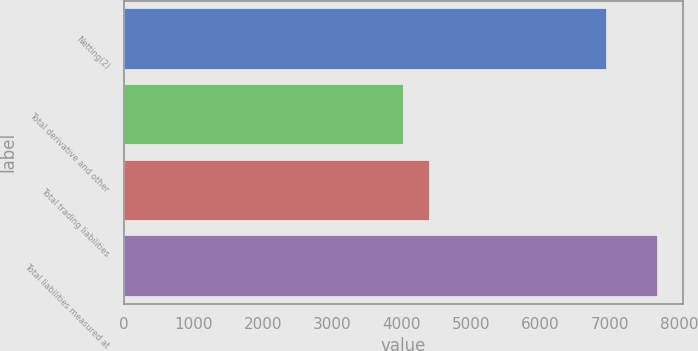<chart> <loc_0><loc_0><loc_500><loc_500><bar_chart><fcel>Netting(2)<fcel>Total derivative and other<fcel>Total trading liabilities<fcel>Total liabilities measured at<nl><fcel>6947<fcel>4026<fcel>4390.6<fcel>7672<nl></chart> 